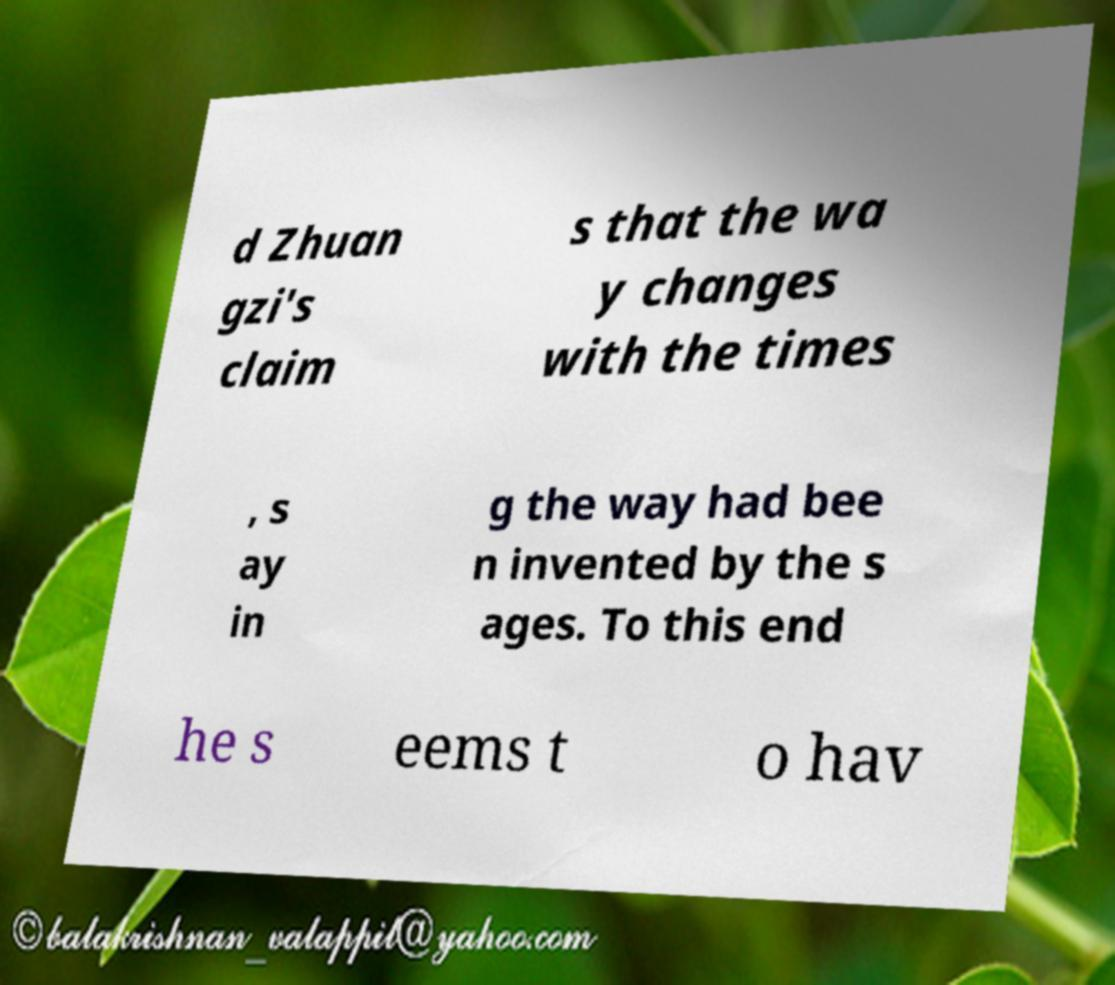Please read and relay the text visible in this image. What does it say? d Zhuan gzi's claim s that the wa y changes with the times , s ay in g the way had bee n invented by the s ages. To this end he s eems t o hav 